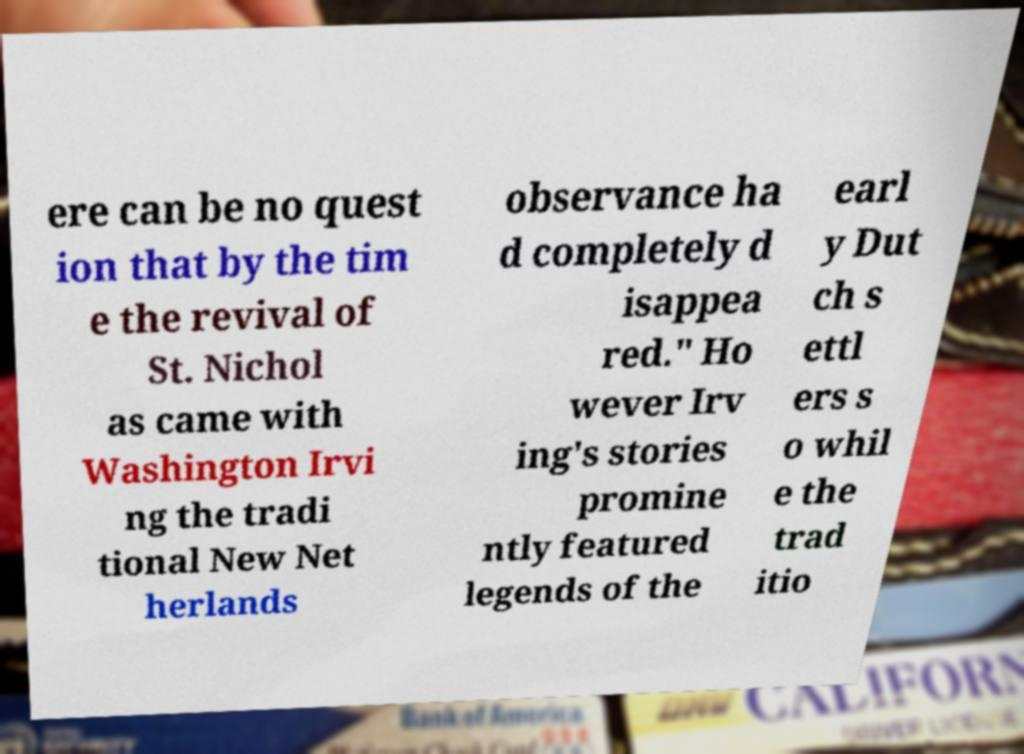I need the written content from this picture converted into text. Can you do that? ere can be no quest ion that by the tim e the revival of St. Nichol as came with Washington Irvi ng the tradi tional New Net herlands observance ha d completely d isappea red." Ho wever Irv ing's stories promine ntly featured legends of the earl y Dut ch s ettl ers s o whil e the trad itio 